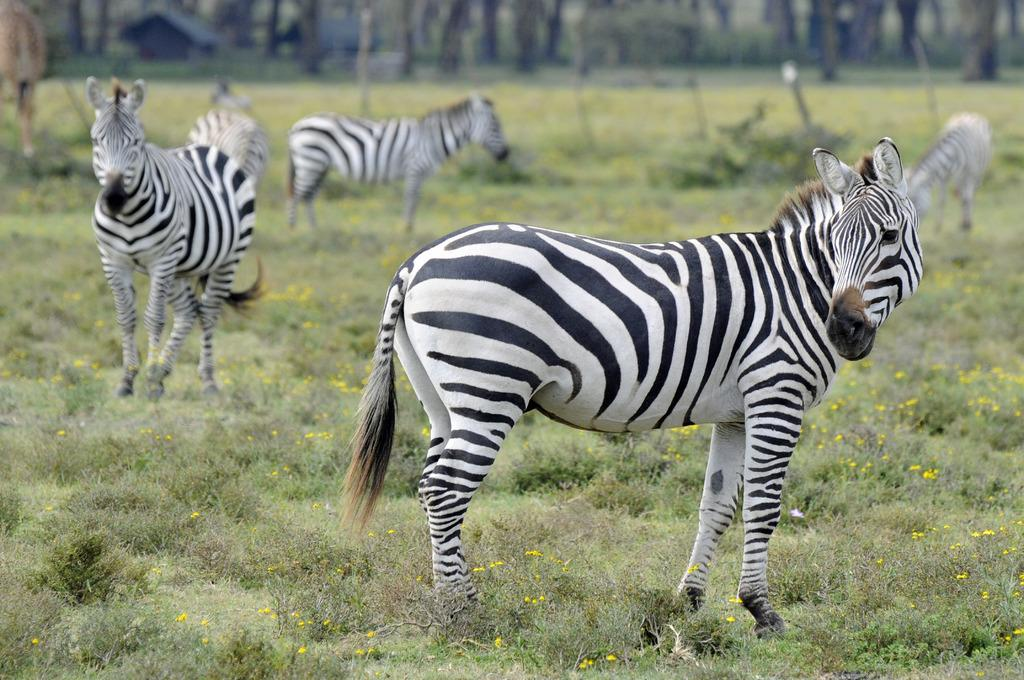What animals can be seen in the image are on the ground? There are zebras on the ground in the image. What can be seen in the distance behind the zebras? There are buildings and trees in the background of the image. What type of vegetation is present on the ground in the image? There are flower plants on the ground in the image to include other elements, such as the buildings and trees in the background. What type of horn can be seen on the zebras in the image? Zebras do not have horns; they have manes and tails. The image does not depict any horns. 